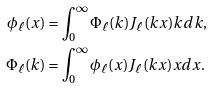<formula> <loc_0><loc_0><loc_500><loc_500>\phi _ { \ell } ( x ) & = \int _ { 0 } ^ { \infty } \Phi _ { \ell } ( k ) J _ { \ell } ( k x ) k d k , \\ \Phi _ { \ell } ( k ) & = \int _ { 0 } ^ { \infty } \phi _ { \ell } ( x ) J _ { \ell } ( k x ) x d x .</formula> 